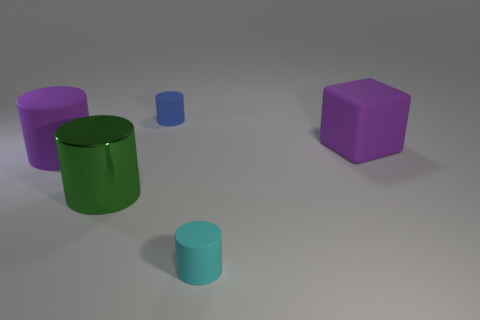How many things are tiny brown metal balls or big purple matte objects in front of the purple cube? In the provided image, there are no tiny brown metal balls visible, nor are there any big purple matte objects in front of the purple cube. The scene includes various geometric shapes with different sizes and colors, but none fit the description given in the question. 